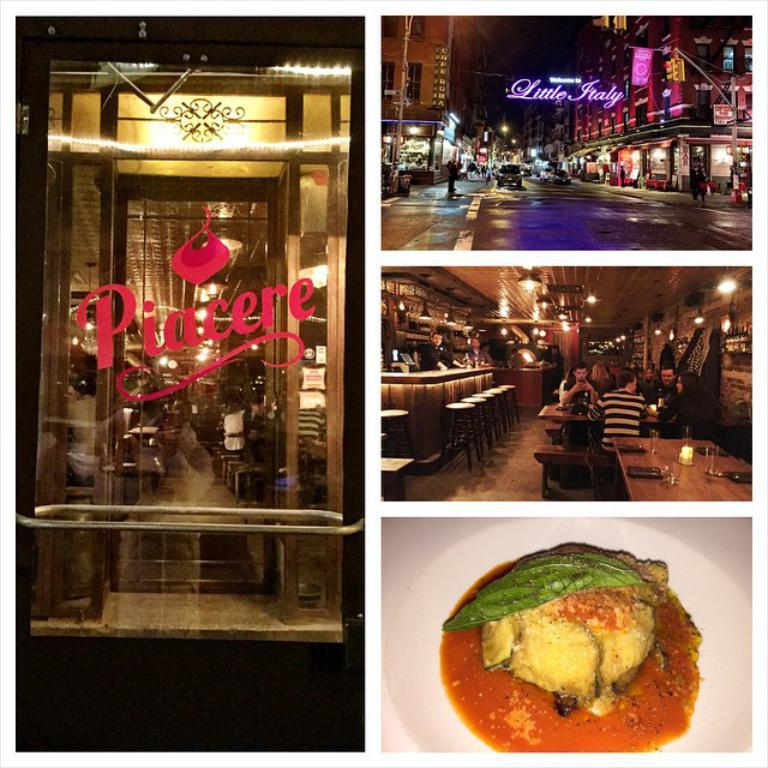What type of image is shown in the collage? The image is a photo collage. What can be seen on the left side of the collage? There is a glass door on the left side of the collage. Can you describe the food item in the collage? There is a food item on a white color plate in the collage. Where is the dog's spot in the collage? There is no dog or spot present in the collage. Can you describe the type of bath in the collage? There is no bath present in the collage. 